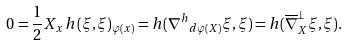Convert formula to latex. <formula><loc_0><loc_0><loc_500><loc_500>0 = \frac { 1 } { 2 } X _ { x } \, h ( \xi , \xi ) _ { \varphi ( x ) } = h ( { \nabla ^ { h } } _ { d \varphi ( X ) } \xi , \xi ) = h ( \overline { \nabla } ^ { \perp } _ { X } \xi , \xi ) .</formula> 